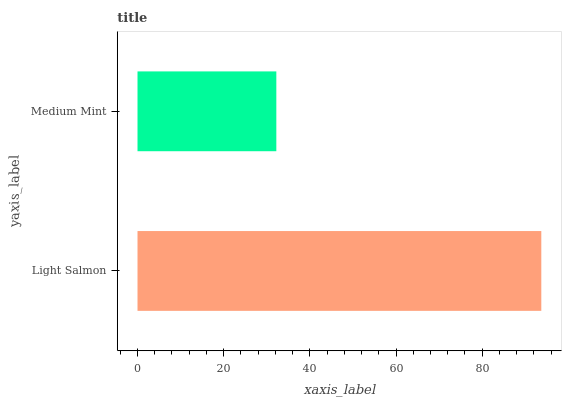Is Medium Mint the minimum?
Answer yes or no. Yes. Is Light Salmon the maximum?
Answer yes or no. Yes. Is Medium Mint the maximum?
Answer yes or no. No. Is Light Salmon greater than Medium Mint?
Answer yes or no. Yes. Is Medium Mint less than Light Salmon?
Answer yes or no. Yes. Is Medium Mint greater than Light Salmon?
Answer yes or no. No. Is Light Salmon less than Medium Mint?
Answer yes or no. No. Is Light Salmon the high median?
Answer yes or no. Yes. Is Medium Mint the low median?
Answer yes or no. Yes. Is Medium Mint the high median?
Answer yes or no. No. Is Light Salmon the low median?
Answer yes or no. No. 